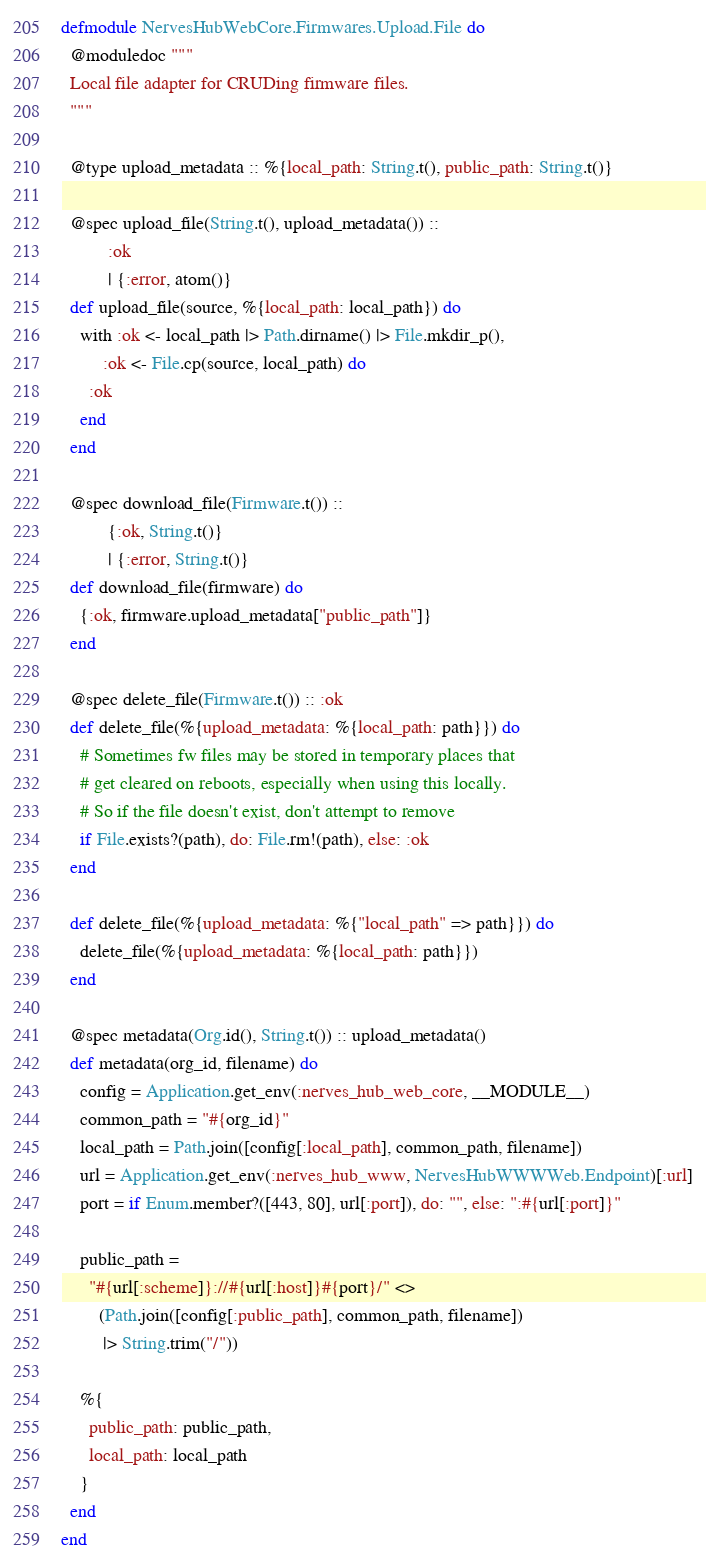<code> <loc_0><loc_0><loc_500><loc_500><_Elixir_>defmodule NervesHubWebCore.Firmwares.Upload.File do
  @moduledoc """
  Local file adapter for CRUDing firmware files.
  """

  @type upload_metadata :: %{local_path: String.t(), public_path: String.t()}

  @spec upload_file(String.t(), upload_metadata()) ::
          :ok
          | {:error, atom()}
  def upload_file(source, %{local_path: local_path}) do
    with :ok <- local_path |> Path.dirname() |> File.mkdir_p(),
         :ok <- File.cp(source, local_path) do
      :ok
    end
  end

  @spec download_file(Firmware.t()) ::
          {:ok, String.t()}
          | {:error, String.t()}
  def download_file(firmware) do
    {:ok, firmware.upload_metadata["public_path"]}
  end

  @spec delete_file(Firmware.t()) :: :ok
  def delete_file(%{upload_metadata: %{local_path: path}}) do
    # Sometimes fw files may be stored in temporary places that
    # get cleared on reboots, especially when using this locally.
    # So if the file doesn't exist, don't attempt to remove
    if File.exists?(path), do: File.rm!(path), else: :ok
  end

  def delete_file(%{upload_metadata: %{"local_path" => path}}) do
    delete_file(%{upload_metadata: %{local_path: path}})
  end

  @spec metadata(Org.id(), String.t()) :: upload_metadata()
  def metadata(org_id, filename) do
    config = Application.get_env(:nerves_hub_web_core, __MODULE__)
    common_path = "#{org_id}"
    local_path = Path.join([config[:local_path], common_path, filename])
    url = Application.get_env(:nerves_hub_www, NervesHubWWWWeb.Endpoint)[:url]
    port = if Enum.member?([443, 80], url[:port]), do: "", else: ":#{url[:port]}"

    public_path =
      "#{url[:scheme]}://#{url[:host]}#{port}/" <>
        (Path.join([config[:public_path], common_path, filename])
         |> String.trim("/"))

    %{
      public_path: public_path,
      local_path: local_path
    }
  end
end
</code> 